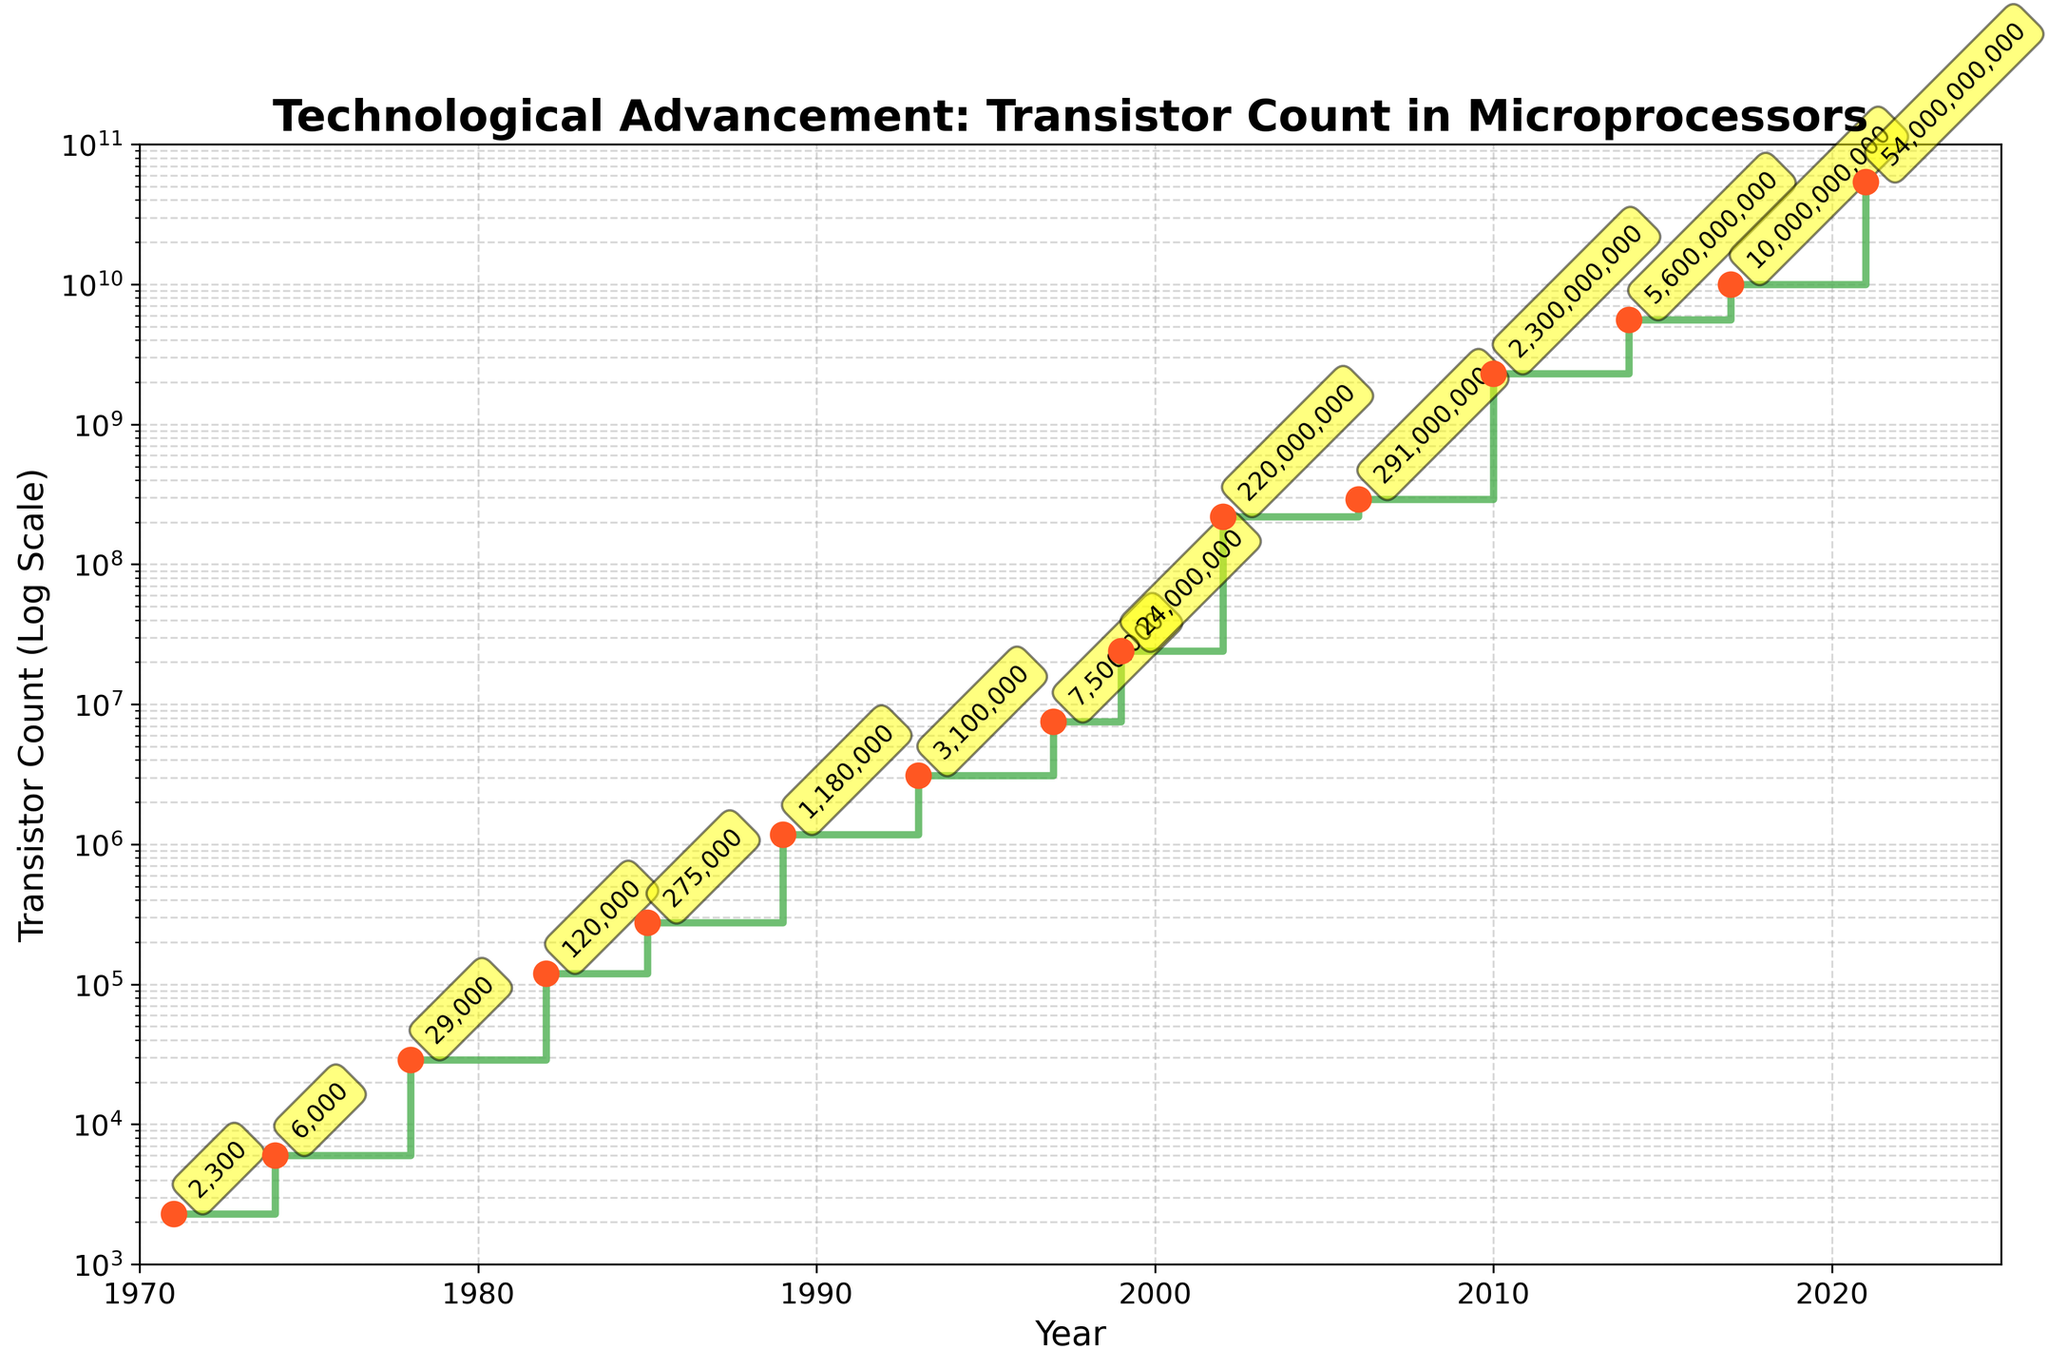What’s the title of the plot? The title is usually found at the top of the figure. In this case, it can be seen directly from the title of the plot.
Answer: Technological Advancement: Transistor Count in Microprocessors What color are the steps and the scatter points? The steps are shown in green, and the scatter points are orange. You can see the steps connecting the scatter points horizontally by following the figure closely.
Answer: Green steps and orange scatter points How many data points are shown in the plot? By counting the number of scatter points or the number of years listed along the x-axis, you can determine the number of data points.
Answer: 15 What is the y-axis scale? The y-axis is scaled logarithmically, as indicated by the "log scale" label and the evenly spaced intervals increasing by powers of 10.
Answer: Logarithmic In which year did the transistor count first exceed one billion? Look along the x-axis to find the year where the y-axis value first crosses the one billion mark (1e9).
Answer: 2002 What is the average increase in transistor count per year between 2014 and 2021? Identify the transistor counts in 2014 (5,600,000,000) and 2021 (54,000,000,000), then subtract the two counts and divide by the number of years between them.
Answer: (54,000,000,000 - 5,600,000,000) / (2021 - 2014) = 6,885,714,286 per year Between which two consecutive years did the transistor count see the largest increase? Find the difference in transistor counts between consecutive years listed and identify the largest increase.
Answer: Between 1999 and 2002 Which has a higher transistor count: the year 1985 or 1989? Compare the values of the transistor count at the years 1985 (275,000) and 1989 (1,180,000).
Answer: 1989 What was the transistor count in the year 1971? Look at the data point corresponding to the year 1971 on the figure.
Answer: 2,300 What is the median transistor count of the data points? List all the transistor counts (2300, 6000, ... 54000000000), sort them, and find the middle value.
Answer: 3,100,000,000 